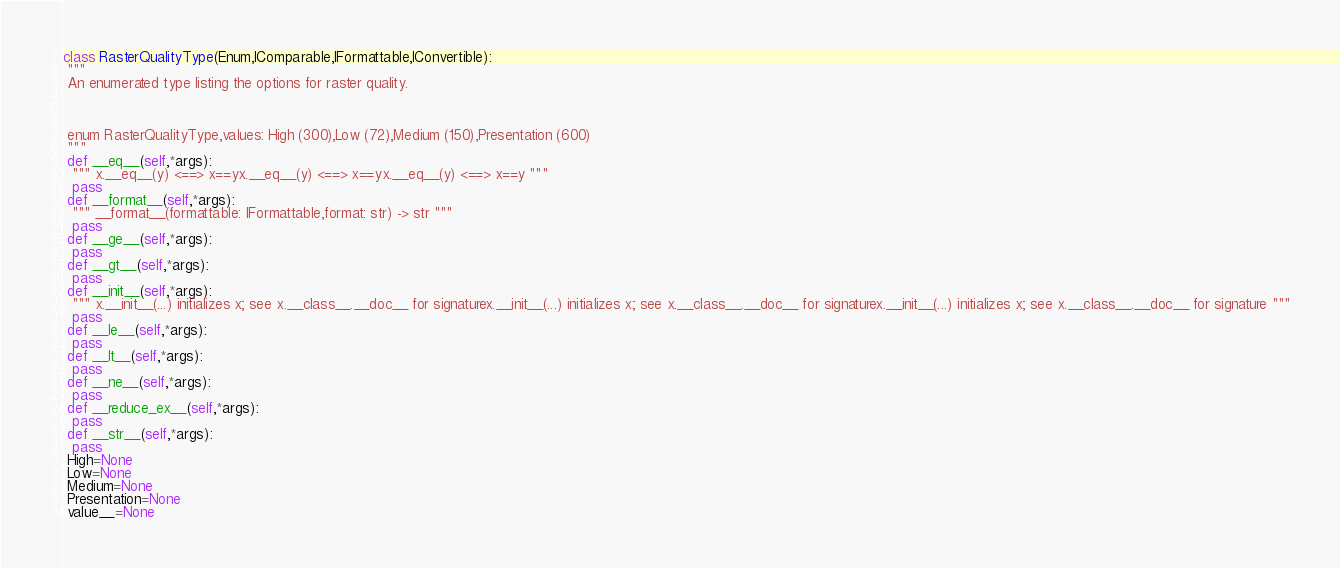Convert code to text. <code><loc_0><loc_0><loc_500><loc_500><_Python_>class RasterQualityType(Enum,IComparable,IFormattable,IConvertible):
 """
 An enumerated type listing the options for raster quality.
 
 enum RasterQualityType,values: High (300),Low (72),Medium (150),Presentation (600)
 """
 def __eq__(self,*args):
  """ x.__eq__(y) <==> x==yx.__eq__(y) <==> x==yx.__eq__(y) <==> x==y """
  pass
 def __format__(self,*args):
  """ __format__(formattable: IFormattable,format: str) -> str """
  pass
 def __ge__(self,*args):
  pass
 def __gt__(self,*args):
  pass
 def __init__(self,*args):
  """ x.__init__(...) initializes x; see x.__class__.__doc__ for signaturex.__init__(...) initializes x; see x.__class__.__doc__ for signaturex.__init__(...) initializes x; see x.__class__.__doc__ for signature """
  pass
 def __le__(self,*args):
  pass
 def __lt__(self,*args):
  pass
 def __ne__(self,*args):
  pass
 def __reduce_ex__(self,*args):
  pass
 def __str__(self,*args):
  pass
 High=None
 Low=None
 Medium=None
 Presentation=None
 value__=None

</code> 